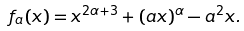Convert formula to latex. <formula><loc_0><loc_0><loc_500><loc_500>f _ { a } ( x ) = x ^ { 2 \alpha + 3 } + ( a x ) ^ { \alpha } - a ^ { 2 } x .</formula> 